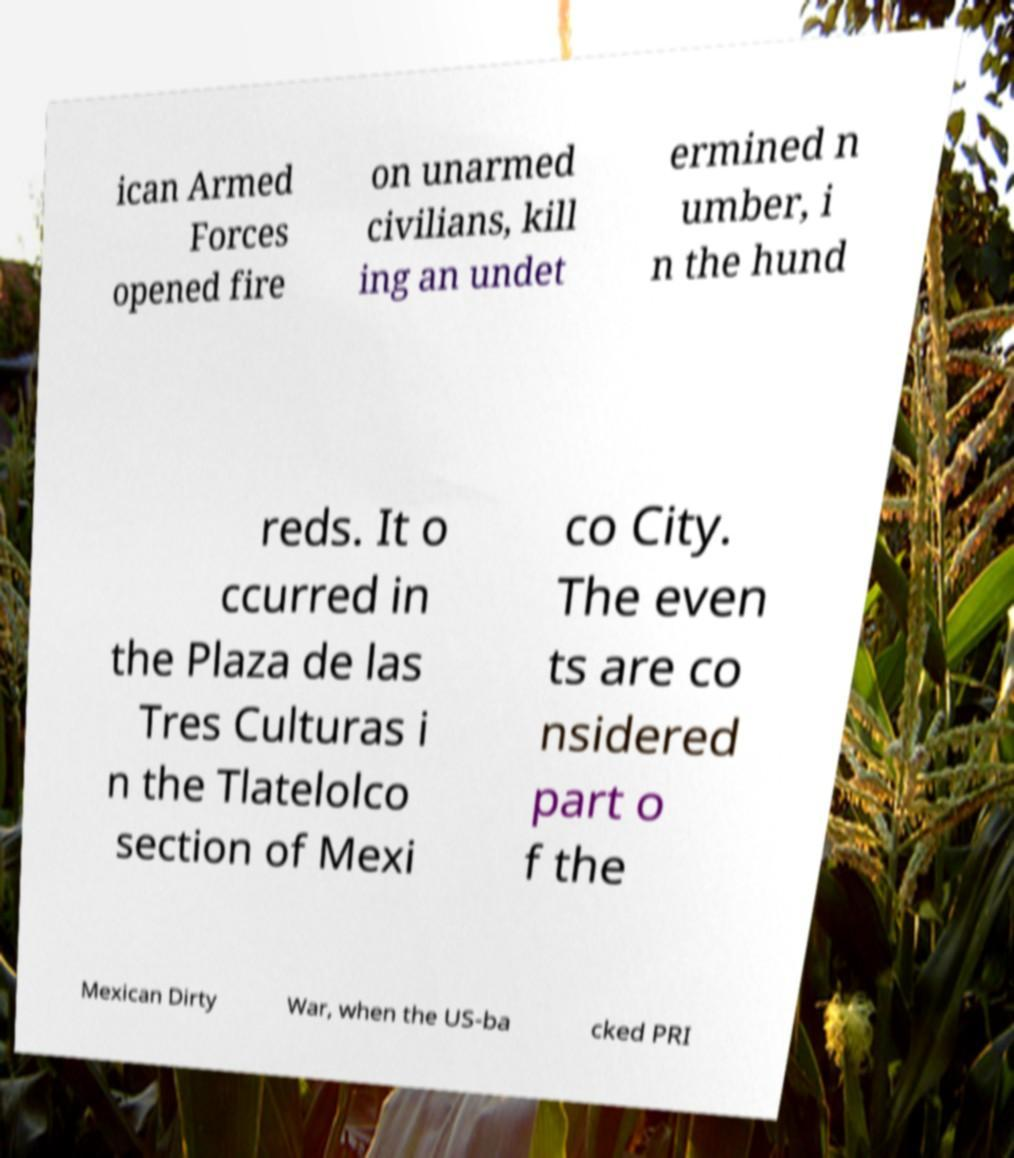Could you extract and type out the text from this image? ican Armed Forces opened fire on unarmed civilians, kill ing an undet ermined n umber, i n the hund reds. It o ccurred in the Plaza de las Tres Culturas i n the Tlatelolco section of Mexi co City. The even ts are co nsidered part o f the Mexican Dirty War, when the US-ba cked PRI 